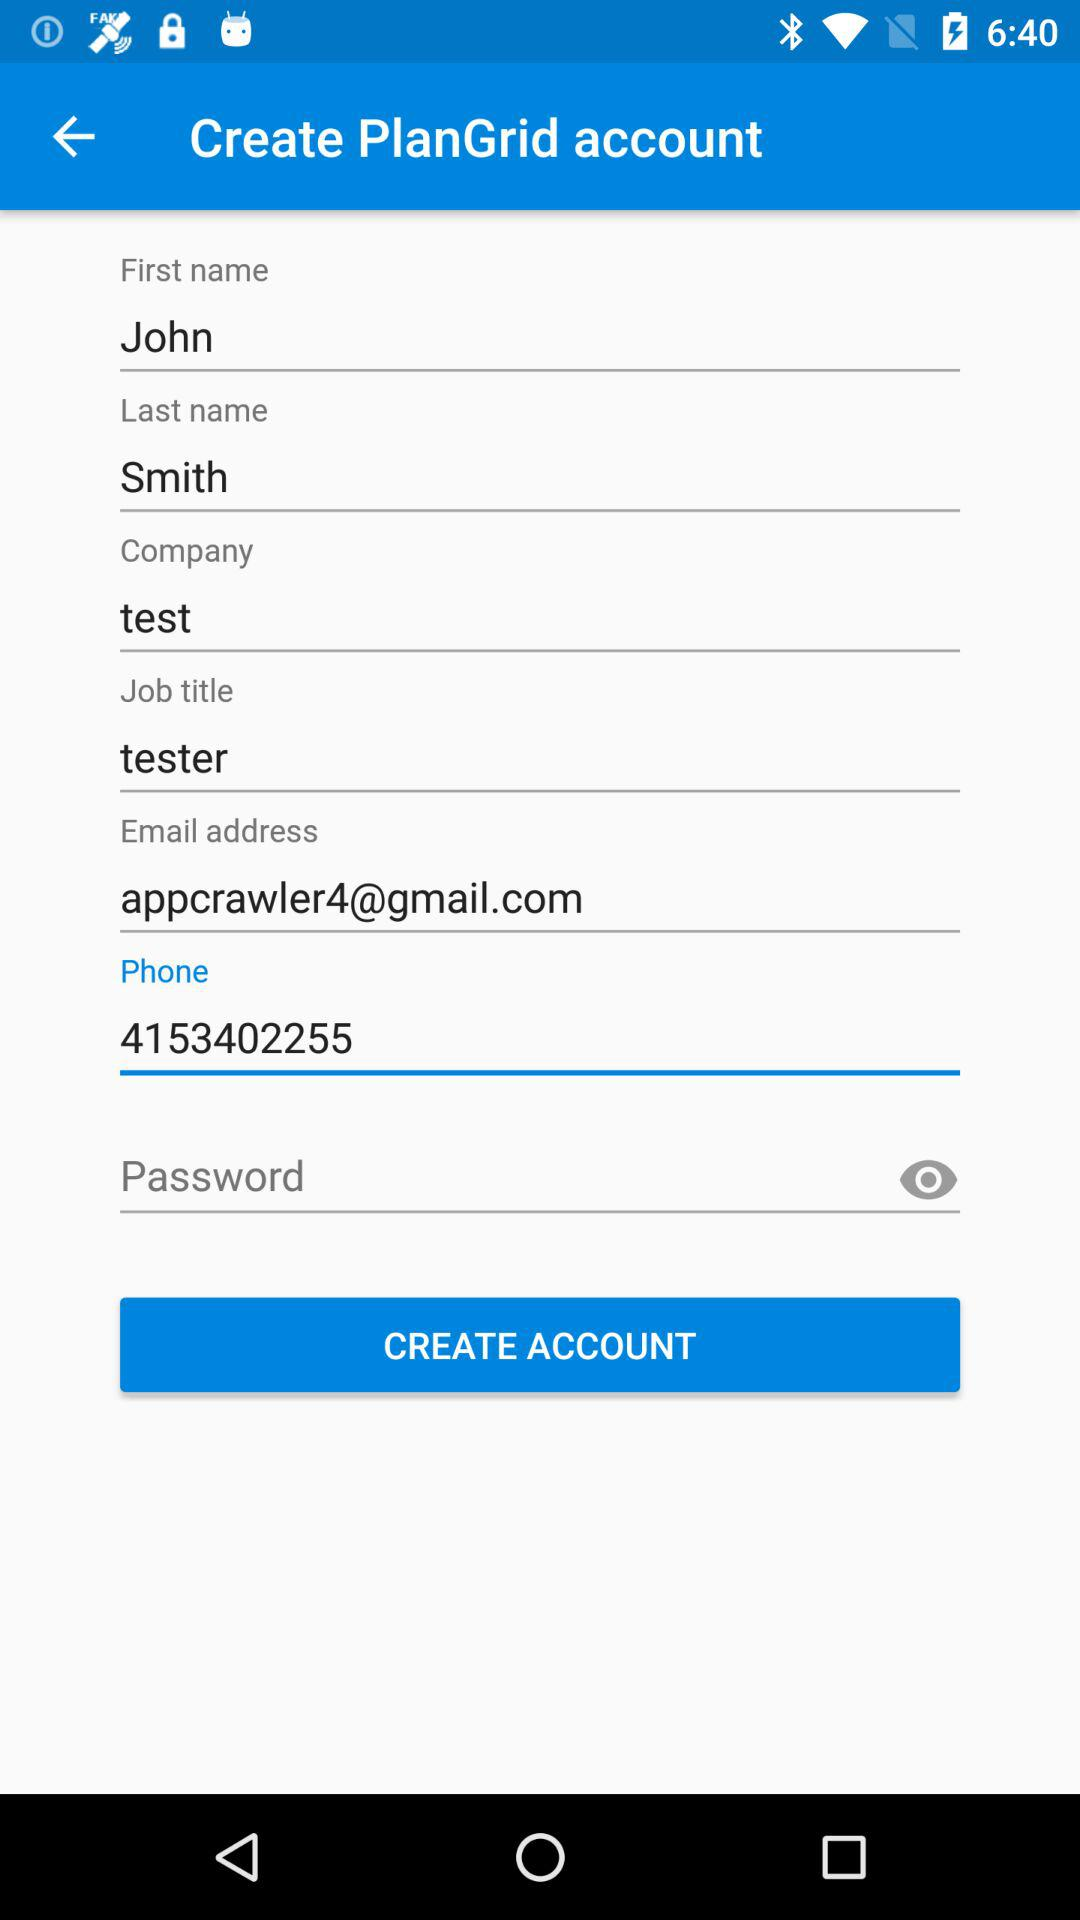What is the email address? The email address is appcrawler4@gmail.com. 